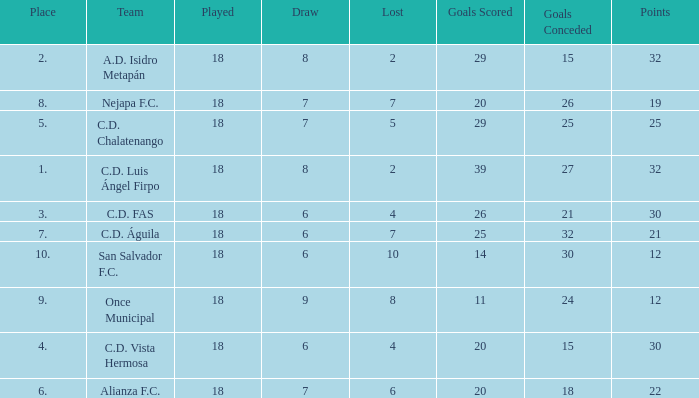What team with a goals conceded smaller than 25, and a place smaller than 3? A.D. Isidro Metapán. 